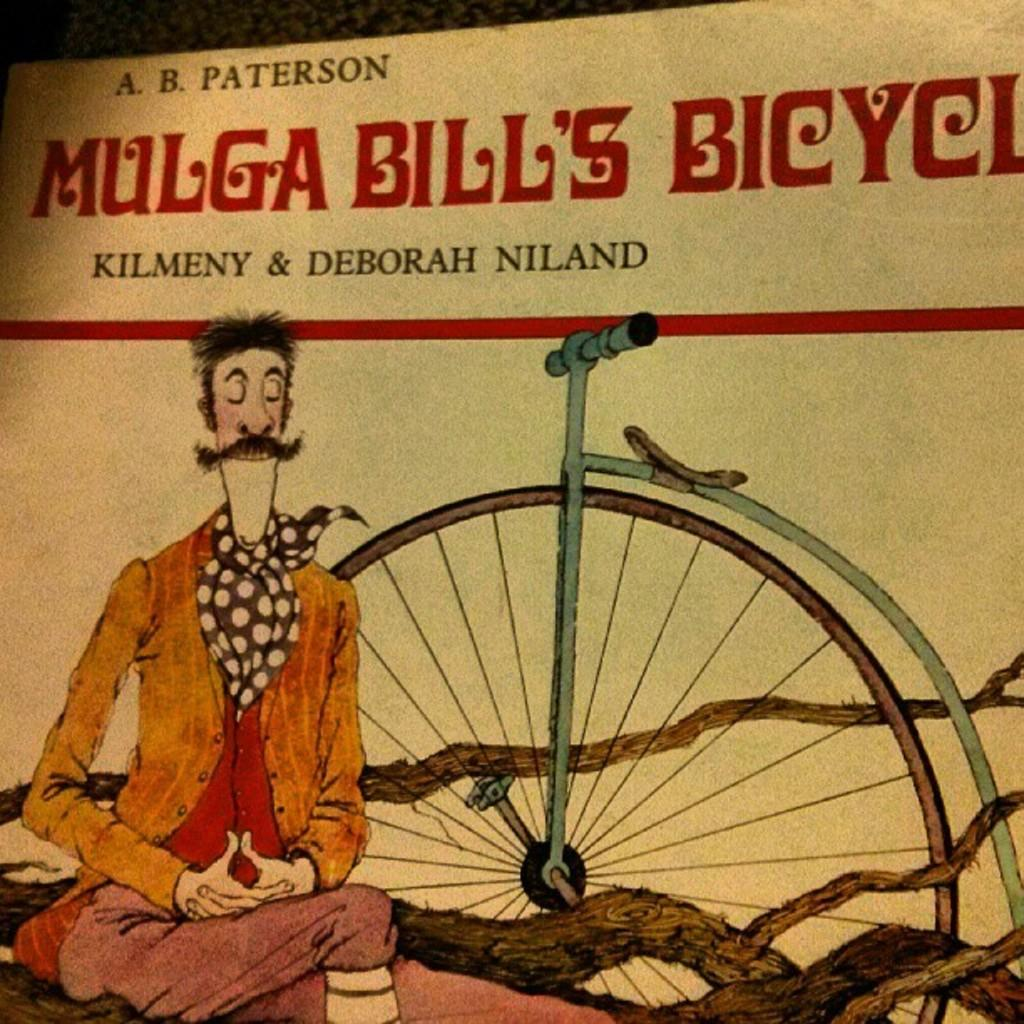What is depicted on the paper in the image? There is an image of a person on the paper. What other object can be seen in the image? There is a bicycle wheel in the image. What else is present on the paper besides the image? Text is visible on the paper. What type of wine is being served in the image? There is no wine present in the image; it features an image of a person, a bicycle wheel, and text on a paper. What caused the person to be depicted on the paper? The facts provided do not give any information about the cause or reason for the person being depicted on the paper. 